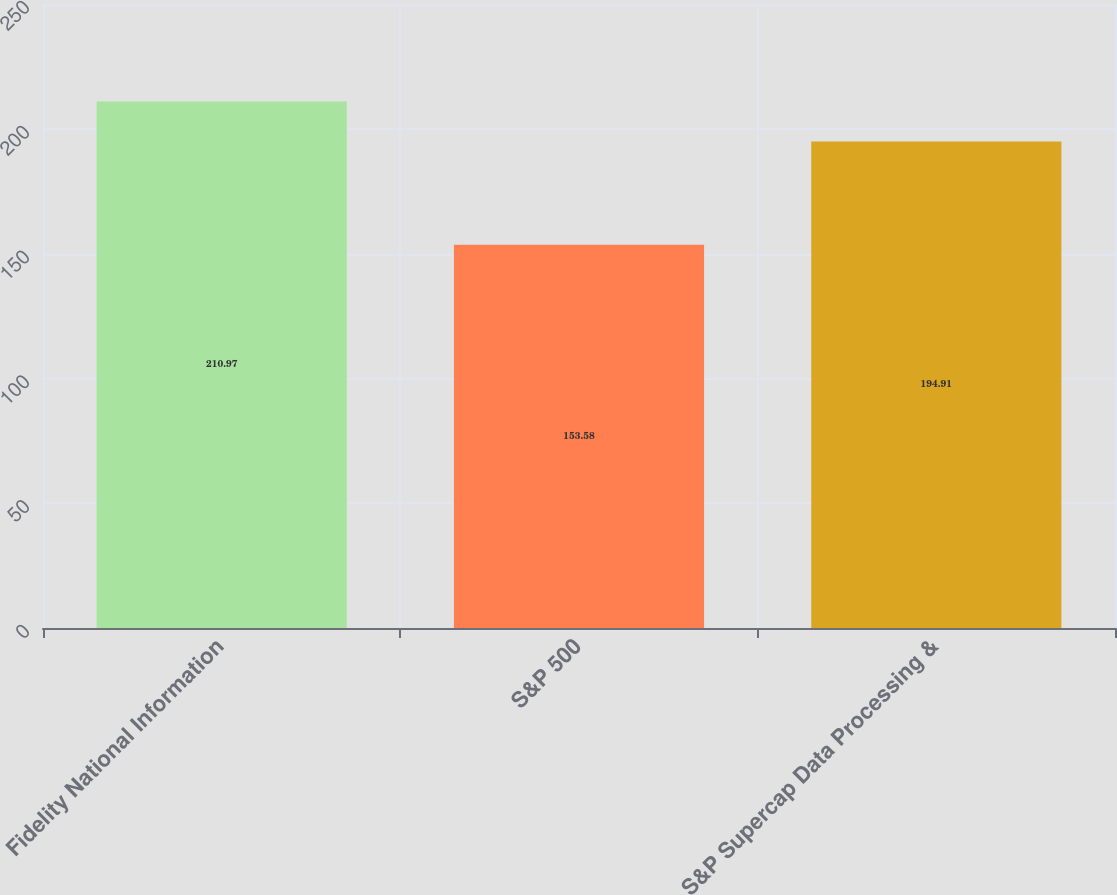Convert chart. <chart><loc_0><loc_0><loc_500><loc_500><bar_chart><fcel>Fidelity National Information<fcel>S&P 500<fcel>S&P Supercap Data Processing &<nl><fcel>210.97<fcel>153.58<fcel>194.91<nl></chart> 